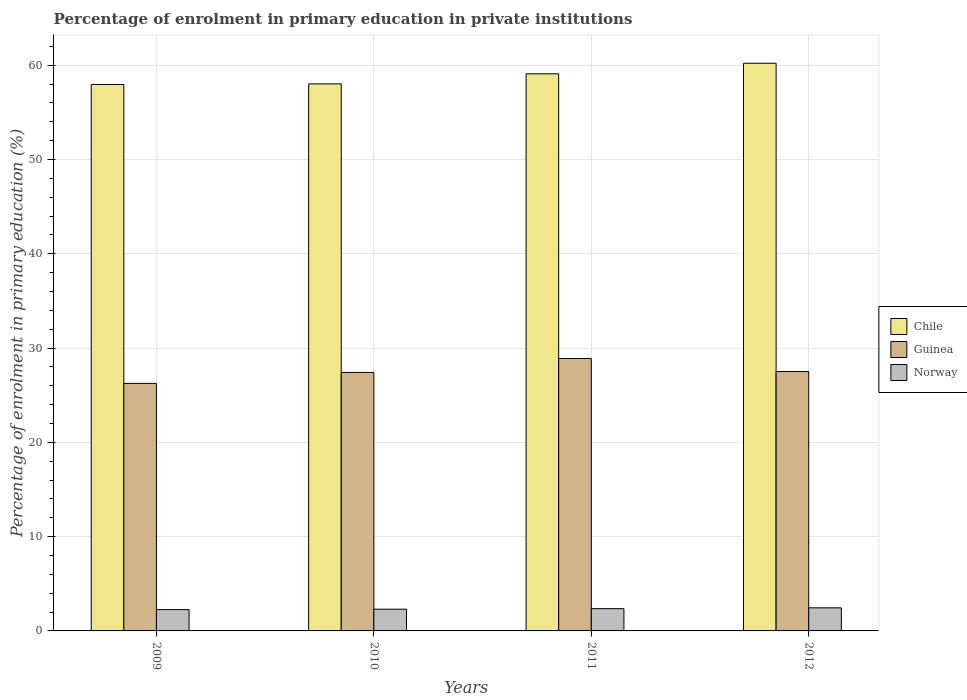How many different coloured bars are there?
Ensure brevity in your answer.  3. Are the number of bars per tick equal to the number of legend labels?
Ensure brevity in your answer.  Yes. Are the number of bars on each tick of the X-axis equal?
Keep it short and to the point. Yes. What is the label of the 3rd group of bars from the left?
Your answer should be very brief. 2011. What is the percentage of enrolment in primary education in Guinea in 2011?
Ensure brevity in your answer.  28.9. Across all years, what is the maximum percentage of enrolment in primary education in Norway?
Your answer should be compact. 2.45. Across all years, what is the minimum percentage of enrolment in primary education in Norway?
Provide a short and direct response. 2.26. In which year was the percentage of enrolment in primary education in Norway maximum?
Your response must be concise. 2012. What is the total percentage of enrolment in primary education in Chile in the graph?
Ensure brevity in your answer.  235.3. What is the difference between the percentage of enrolment in primary education in Guinea in 2010 and that in 2012?
Offer a very short reply. -0.09. What is the difference between the percentage of enrolment in primary education in Guinea in 2011 and the percentage of enrolment in primary education in Chile in 2010?
Give a very brief answer. -29.13. What is the average percentage of enrolment in primary education in Chile per year?
Make the answer very short. 58.83. In the year 2009, what is the difference between the percentage of enrolment in primary education in Guinea and percentage of enrolment in primary education in Norway?
Your answer should be compact. 23.99. What is the ratio of the percentage of enrolment in primary education in Chile in 2010 to that in 2012?
Provide a short and direct response. 0.96. Is the percentage of enrolment in primary education in Norway in 2010 less than that in 2011?
Make the answer very short. Yes. What is the difference between the highest and the second highest percentage of enrolment in primary education in Chile?
Make the answer very short. 1.12. What is the difference between the highest and the lowest percentage of enrolment in primary education in Chile?
Your answer should be very brief. 2.25. Is it the case that in every year, the sum of the percentage of enrolment in primary education in Guinea and percentage of enrolment in primary education in Norway is greater than the percentage of enrolment in primary education in Chile?
Your answer should be very brief. No. How many bars are there?
Your answer should be compact. 12. Are all the bars in the graph horizontal?
Your response must be concise. No. Does the graph contain any zero values?
Ensure brevity in your answer.  No. Does the graph contain grids?
Your answer should be compact. Yes. How many legend labels are there?
Offer a terse response. 3. How are the legend labels stacked?
Make the answer very short. Vertical. What is the title of the graph?
Keep it short and to the point. Percentage of enrolment in primary education in private institutions. Does "Serbia" appear as one of the legend labels in the graph?
Keep it short and to the point. No. What is the label or title of the X-axis?
Your answer should be very brief. Years. What is the label or title of the Y-axis?
Your answer should be very brief. Percentage of enrolment in primary education (%). What is the Percentage of enrolment in primary education (%) in Chile in 2009?
Your answer should be very brief. 57.96. What is the Percentage of enrolment in primary education (%) of Guinea in 2009?
Provide a succinct answer. 26.26. What is the Percentage of enrolment in primary education (%) in Norway in 2009?
Ensure brevity in your answer.  2.26. What is the Percentage of enrolment in primary education (%) of Chile in 2010?
Keep it short and to the point. 58.03. What is the Percentage of enrolment in primary education (%) of Guinea in 2010?
Your response must be concise. 27.42. What is the Percentage of enrolment in primary education (%) in Norway in 2010?
Offer a terse response. 2.31. What is the Percentage of enrolment in primary education (%) of Chile in 2011?
Your response must be concise. 59.1. What is the Percentage of enrolment in primary education (%) of Guinea in 2011?
Give a very brief answer. 28.9. What is the Percentage of enrolment in primary education (%) in Norway in 2011?
Provide a succinct answer. 2.36. What is the Percentage of enrolment in primary education (%) in Chile in 2012?
Give a very brief answer. 60.21. What is the Percentage of enrolment in primary education (%) in Guinea in 2012?
Ensure brevity in your answer.  27.51. What is the Percentage of enrolment in primary education (%) of Norway in 2012?
Provide a short and direct response. 2.45. Across all years, what is the maximum Percentage of enrolment in primary education (%) in Chile?
Your answer should be compact. 60.21. Across all years, what is the maximum Percentage of enrolment in primary education (%) in Guinea?
Give a very brief answer. 28.9. Across all years, what is the maximum Percentage of enrolment in primary education (%) of Norway?
Ensure brevity in your answer.  2.45. Across all years, what is the minimum Percentage of enrolment in primary education (%) of Chile?
Your answer should be very brief. 57.96. Across all years, what is the minimum Percentage of enrolment in primary education (%) in Guinea?
Your response must be concise. 26.26. Across all years, what is the minimum Percentage of enrolment in primary education (%) in Norway?
Provide a short and direct response. 2.26. What is the total Percentage of enrolment in primary education (%) of Chile in the graph?
Give a very brief answer. 235.3. What is the total Percentage of enrolment in primary education (%) in Guinea in the graph?
Your answer should be compact. 110.09. What is the total Percentage of enrolment in primary education (%) in Norway in the graph?
Your response must be concise. 9.38. What is the difference between the Percentage of enrolment in primary education (%) of Chile in 2009 and that in 2010?
Provide a succinct answer. -0.07. What is the difference between the Percentage of enrolment in primary education (%) in Guinea in 2009 and that in 2010?
Give a very brief answer. -1.17. What is the difference between the Percentage of enrolment in primary education (%) in Norway in 2009 and that in 2010?
Offer a very short reply. -0.04. What is the difference between the Percentage of enrolment in primary education (%) of Chile in 2009 and that in 2011?
Ensure brevity in your answer.  -1.13. What is the difference between the Percentage of enrolment in primary education (%) in Guinea in 2009 and that in 2011?
Keep it short and to the point. -2.64. What is the difference between the Percentage of enrolment in primary education (%) in Norway in 2009 and that in 2011?
Give a very brief answer. -0.1. What is the difference between the Percentage of enrolment in primary education (%) in Chile in 2009 and that in 2012?
Give a very brief answer. -2.25. What is the difference between the Percentage of enrolment in primary education (%) of Guinea in 2009 and that in 2012?
Provide a succinct answer. -1.26. What is the difference between the Percentage of enrolment in primary education (%) of Norway in 2009 and that in 2012?
Offer a terse response. -0.19. What is the difference between the Percentage of enrolment in primary education (%) in Chile in 2010 and that in 2011?
Your response must be concise. -1.07. What is the difference between the Percentage of enrolment in primary education (%) in Guinea in 2010 and that in 2011?
Offer a terse response. -1.48. What is the difference between the Percentage of enrolment in primary education (%) of Norway in 2010 and that in 2011?
Your answer should be very brief. -0.06. What is the difference between the Percentage of enrolment in primary education (%) of Chile in 2010 and that in 2012?
Keep it short and to the point. -2.18. What is the difference between the Percentage of enrolment in primary education (%) of Guinea in 2010 and that in 2012?
Make the answer very short. -0.09. What is the difference between the Percentage of enrolment in primary education (%) in Norway in 2010 and that in 2012?
Offer a terse response. -0.14. What is the difference between the Percentage of enrolment in primary education (%) of Chile in 2011 and that in 2012?
Ensure brevity in your answer.  -1.12. What is the difference between the Percentage of enrolment in primary education (%) of Guinea in 2011 and that in 2012?
Your answer should be compact. 1.39. What is the difference between the Percentage of enrolment in primary education (%) in Norway in 2011 and that in 2012?
Keep it short and to the point. -0.09. What is the difference between the Percentage of enrolment in primary education (%) of Chile in 2009 and the Percentage of enrolment in primary education (%) of Guinea in 2010?
Your answer should be compact. 30.54. What is the difference between the Percentage of enrolment in primary education (%) of Chile in 2009 and the Percentage of enrolment in primary education (%) of Norway in 2010?
Give a very brief answer. 55.66. What is the difference between the Percentage of enrolment in primary education (%) of Guinea in 2009 and the Percentage of enrolment in primary education (%) of Norway in 2010?
Provide a short and direct response. 23.95. What is the difference between the Percentage of enrolment in primary education (%) of Chile in 2009 and the Percentage of enrolment in primary education (%) of Guinea in 2011?
Make the answer very short. 29.06. What is the difference between the Percentage of enrolment in primary education (%) in Chile in 2009 and the Percentage of enrolment in primary education (%) in Norway in 2011?
Offer a very short reply. 55.6. What is the difference between the Percentage of enrolment in primary education (%) of Guinea in 2009 and the Percentage of enrolment in primary education (%) of Norway in 2011?
Give a very brief answer. 23.89. What is the difference between the Percentage of enrolment in primary education (%) of Chile in 2009 and the Percentage of enrolment in primary education (%) of Guinea in 2012?
Offer a very short reply. 30.45. What is the difference between the Percentage of enrolment in primary education (%) of Chile in 2009 and the Percentage of enrolment in primary education (%) of Norway in 2012?
Offer a very short reply. 55.51. What is the difference between the Percentage of enrolment in primary education (%) in Guinea in 2009 and the Percentage of enrolment in primary education (%) in Norway in 2012?
Give a very brief answer. 23.81. What is the difference between the Percentage of enrolment in primary education (%) of Chile in 2010 and the Percentage of enrolment in primary education (%) of Guinea in 2011?
Your response must be concise. 29.13. What is the difference between the Percentage of enrolment in primary education (%) in Chile in 2010 and the Percentage of enrolment in primary education (%) in Norway in 2011?
Your response must be concise. 55.67. What is the difference between the Percentage of enrolment in primary education (%) of Guinea in 2010 and the Percentage of enrolment in primary education (%) of Norway in 2011?
Offer a very short reply. 25.06. What is the difference between the Percentage of enrolment in primary education (%) in Chile in 2010 and the Percentage of enrolment in primary education (%) in Guinea in 2012?
Ensure brevity in your answer.  30.52. What is the difference between the Percentage of enrolment in primary education (%) of Chile in 2010 and the Percentage of enrolment in primary education (%) of Norway in 2012?
Offer a terse response. 55.58. What is the difference between the Percentage of enrolment in primary education (%) in Guinea in 2010 and the Percentage of enrolment in primary education (%) in Norway in 2012?
Provide a short and direct response. 24.97. What is the difference between the Percentage of enrolment in primary education (%) of Chile in 2011 and the Percentage of enrolment in primary education (%) of Guinea in 2012?
Your answer should be compact. 31.58. What is the difference between the Percentage of enrolment in primary education (%) of Chile in 2011 and the Percentage of enrolment in primary education (%) of Norway in 2012?
Offer a terse response. 56.65. What is the difference between the Percentage of enrolment in primary education (%) in Guinea in 2011 and the Percentage of enrolment in primary education (%) in Norway in 2012?
Provide a short and direct response. 26.45. What is the average Percentage of enrolment in primary education (%) in Chile per year?
Provide a short and direct response. 58.83. What is the average Percentage of enrolment in primary education (%) of Guinea per year?
Keep it short and to the point. 27.52. What is the average Percentage of enrolment in primary education (%) of Norway per year?
Make the answer very short. 2.35. In the year 2009, what is the difference between the Percentage of enrolment in primary education (%) in Chile and Percentage of enrolment in primary education (%) in Guinea?
Ensure brevity in your answer.  31.71. In the year 2009, what is the difference between the Percentage of enrolment in primary education (%) of Chile and Percentage of enrolment in primary education (%) of Norway?
Give a very brief answer. 55.7. In the year 2009, what is the difference between the Percentage of enrolment in primary education (%) of Guinea and Percentage of enrolment in primary education (%) of Norway?
Provide a succinct answer. 23.99. In the year 2010, what is the difference between the Percentage of enrolment in primary education (%) of Chile and Percentage of enrolment in primary education (%) of Guinea?
Make the answer very short. 30.61. In the year 2010, what is the difference between the Percentage of enrolment in primary education (%) of Chile and Percentage of enrolment in primary education (%) of Norway?
Your answer should be compact. 55.72. In the year 2010, what is the difference between the Percentage of enrolment in primary education (%) in Guinea and Percentage of enrolment in primary education (%) in Norway?
Your answer should be very brief. 25.11. In the year 2011, what is the difference between the Percentage of enrolment in primary education (%) in Chile and Percentage of enrolment in primary education (%) in Guinea?
Make the answer very short. 30.2. In the year 2011, what is the difference between the Percentage of enrolment in primary education (%) in Chile and Percentage of enrolment in primary education (%) in Norway?
Ensure brevity in your answer.  56.73. In the year 2011, what is the difference between the Percentage of enrolment in primary education (%) of Guinea and Percentage of enrolment in primary education (%) of Norway?
Provide a short and direct response. 26.53. In the year 2012, what is the difference between the Percentage of enrolment in primary education (%) of Chile and Percentage of enrolment in primary education (%) of Guinea?
Keep it short and to the point. 32.7. In the year 2012, what is the difference between the Percentage of enrolment in primary education (%) of Chile and Percentage of enrolment in primary education (%) of Norway?
Keep it short and to the point. 57.76. In the year 2012, what is the difference between the Percentage of enrolment in primary education (%) of Guinea and Percentage of enrolment in primary education (%) of Norway?
Keep it short and to the point. 25.06. What is the ratio of the Percentage of enrolment in primary education (%) in Guinea in 2009 to that in 2010?
Provide a succinct answer. 0.96. What is the ratio of the Percentage of enrolment in primary education (%) of Norway in 2009 to that in 2010?
Your answer should be very brief. 0.98. What is the ratio of the Percentage of enrolment in primary education (%) in Chile in 2009 to that in 2011?
Provide a succinct answer. 0.98. What is the ratio of the Percentage of enrolment in primary education (%) of Guinea in 2009 to that in 2011?
Provide a short and direct response. 0.91. What is the ratio of the Percentage of enrolment in primary education (%) in Norway in 2009 to that in 2011?
Your answer should be compact. 0.96. What is the ratio of the Percentage of enrolment in primary education (%) in Chile in 2009 to that in 2012?
Your answer should be compact. 0.96. What is the ratio of the Percentage of enrolment in primary education (%) in Guinea in 2009 to that in 2012?
Offer a very short reply. 0.95. What is the ratio of the Percentage of enrolment in primary education (%) of Norway in 2009 to that in 2012?
Give a very brief answer. 0.92. What is the ratio of the Percentage of enrolment in primary education (%) of Guinea in 2010 to that in 2011?
Your response must be concise. 0.95. What is the ratio of the Percentage of enrolment in primary education (%) in Norway in 2010 to that in 2011?
Make the answer very short. 0.98. What is the ratio of the Percentage of enrolment in primary education (%) of Chile in 2010 to that in 2012?
Give a very brief answer. 0.96. What is the ratio of the Percentage of enrolment in primary education (%) of Norway in 2010 to that in 2012?
Make the answer very short. 0.94. What is the ratio of the Percentage of enrolment in primary education (%) of Chile in 2011 to that in 2012?
Keep it short and to the point. 0.98. What is the ratio of the Percentage of enrolment in primary education (%) of Guinea in 2011 to that in 2012?
Offer a terse response. 1.05. What is the ratio of the Percentage of enrolment in primary education (%) of Norway in 2011 to that in 2012?
Provide a succinct answer. 0.96. What is the difference between the highest and the second highest Percentage of enrolment in primary education (%) of Chile?
Offer a terse response. 1.12. What is the difference between the highest and the second highest Percentage of enrolment in primary education (%) of Guinea?
Make the answer very short. 1.39. What is the difference between the highest and the second highest Percentage of enrolment in primary education (%) in Norway?
Your answer should be compact. 0.09. What is the difference between the highest and the lowest Percentage of enrolment in primary education (%) in Chile?
Offer a terse response. 2.25. What is the difference between the highest and the lowest Percentage of enrolment in primary education (%) of Guinea?
Offer a very short reply. 2.64. What is the difference between the highest and the lowest Percentage of enrolment in primary education (%) of Norway?
Your answer should be compact. 0.19. 